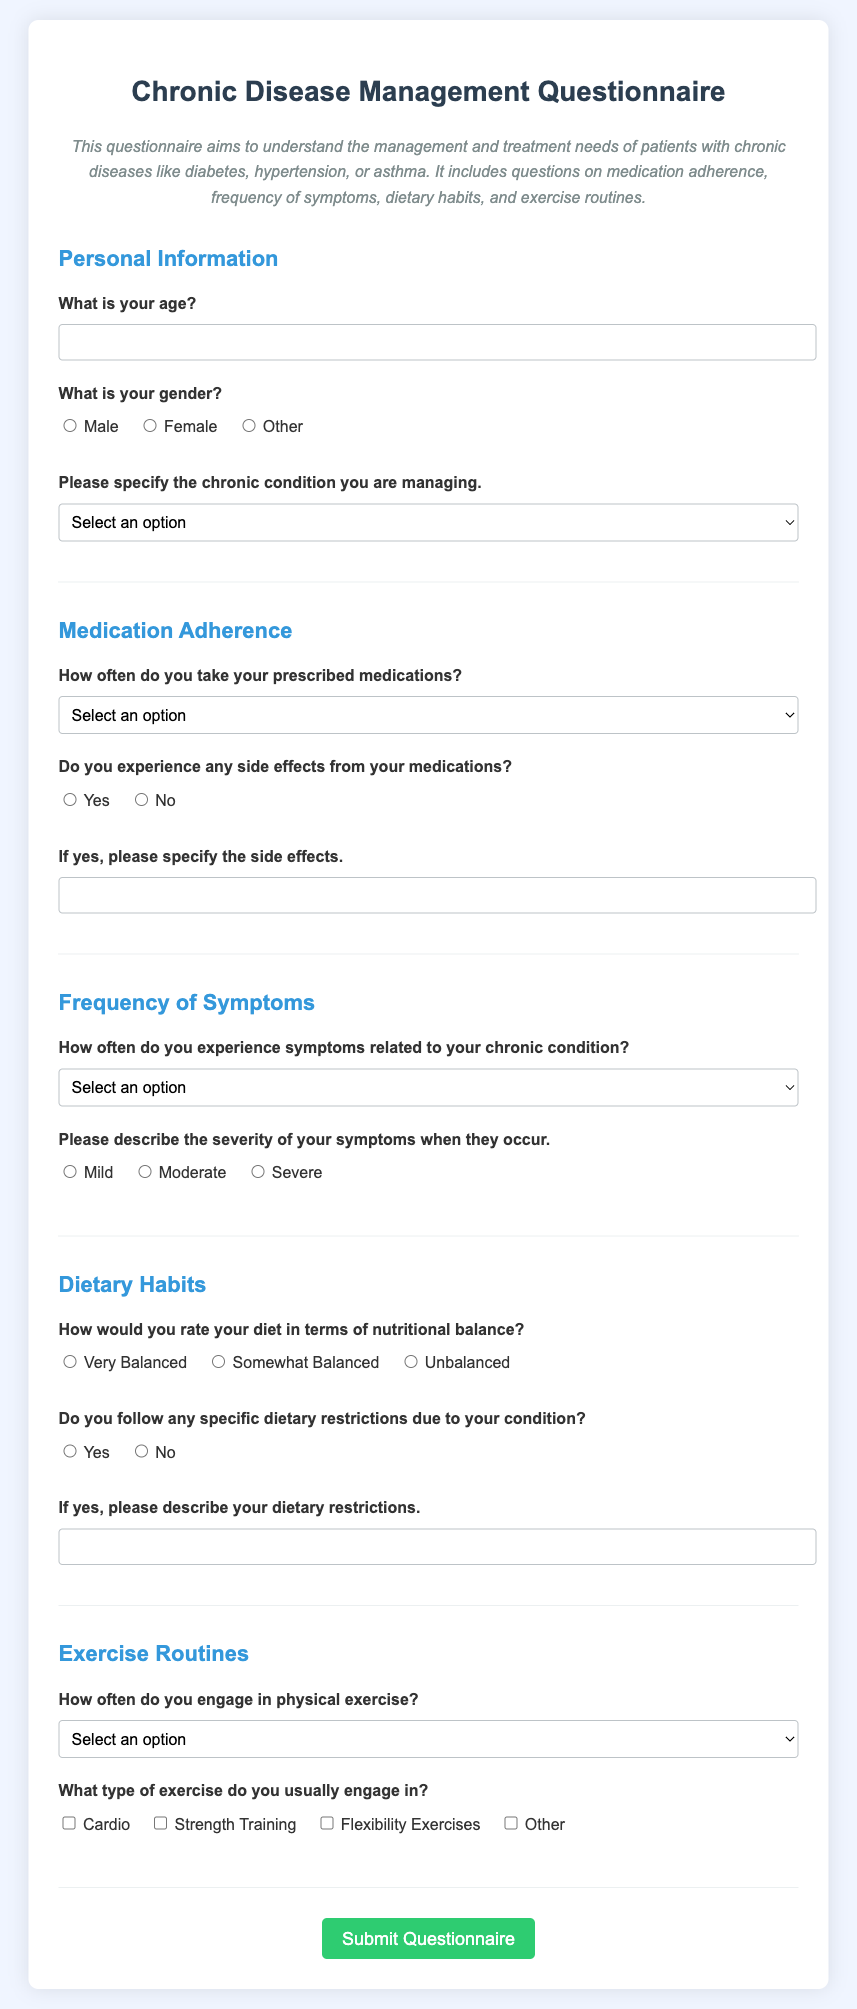What is the title of the questionnaire? The title is indicated at the top of the document.
Answer: Chronic Disease Management Questionnaire What is the purpose of the questionnaire? The purpose is stated in the description section of the document.
Answer: To understand the management and treatment needs of patients with chronic diseases How many sections are there in the questionnaire? The sections are clearly divided, and their headers can be counted.
Answer: Five What type of chronic conditions can be specified in the questionnaire? The options listed in the droplist provide the answer.
Answer: Diabetes, Hypertension, Asthma, Other What is the required response format for the medication adherence question? The question provides multiple-choice answers that must be selected.
Answer: Select from options What frequency of symptoms can patients report in the questionnaire? The answer is found in the options given for symptom frequency.
Answer: Daily, Weekly, Monthly, Rarely, Never What information is requested if a patient experiences side effects from medications? The question asks for a specification of side effects if the answer is yes.
Answer: Description of side effects How is exercise frequency assessed in the questionnaire? The question offers a list of options from which participants can choose their frequency.
Answer: Select from options What do patients need to describe if they follow any dietary restrictions? The question specifies that a description is required if the answer is yes.
Answer: Dietary restrictions description 